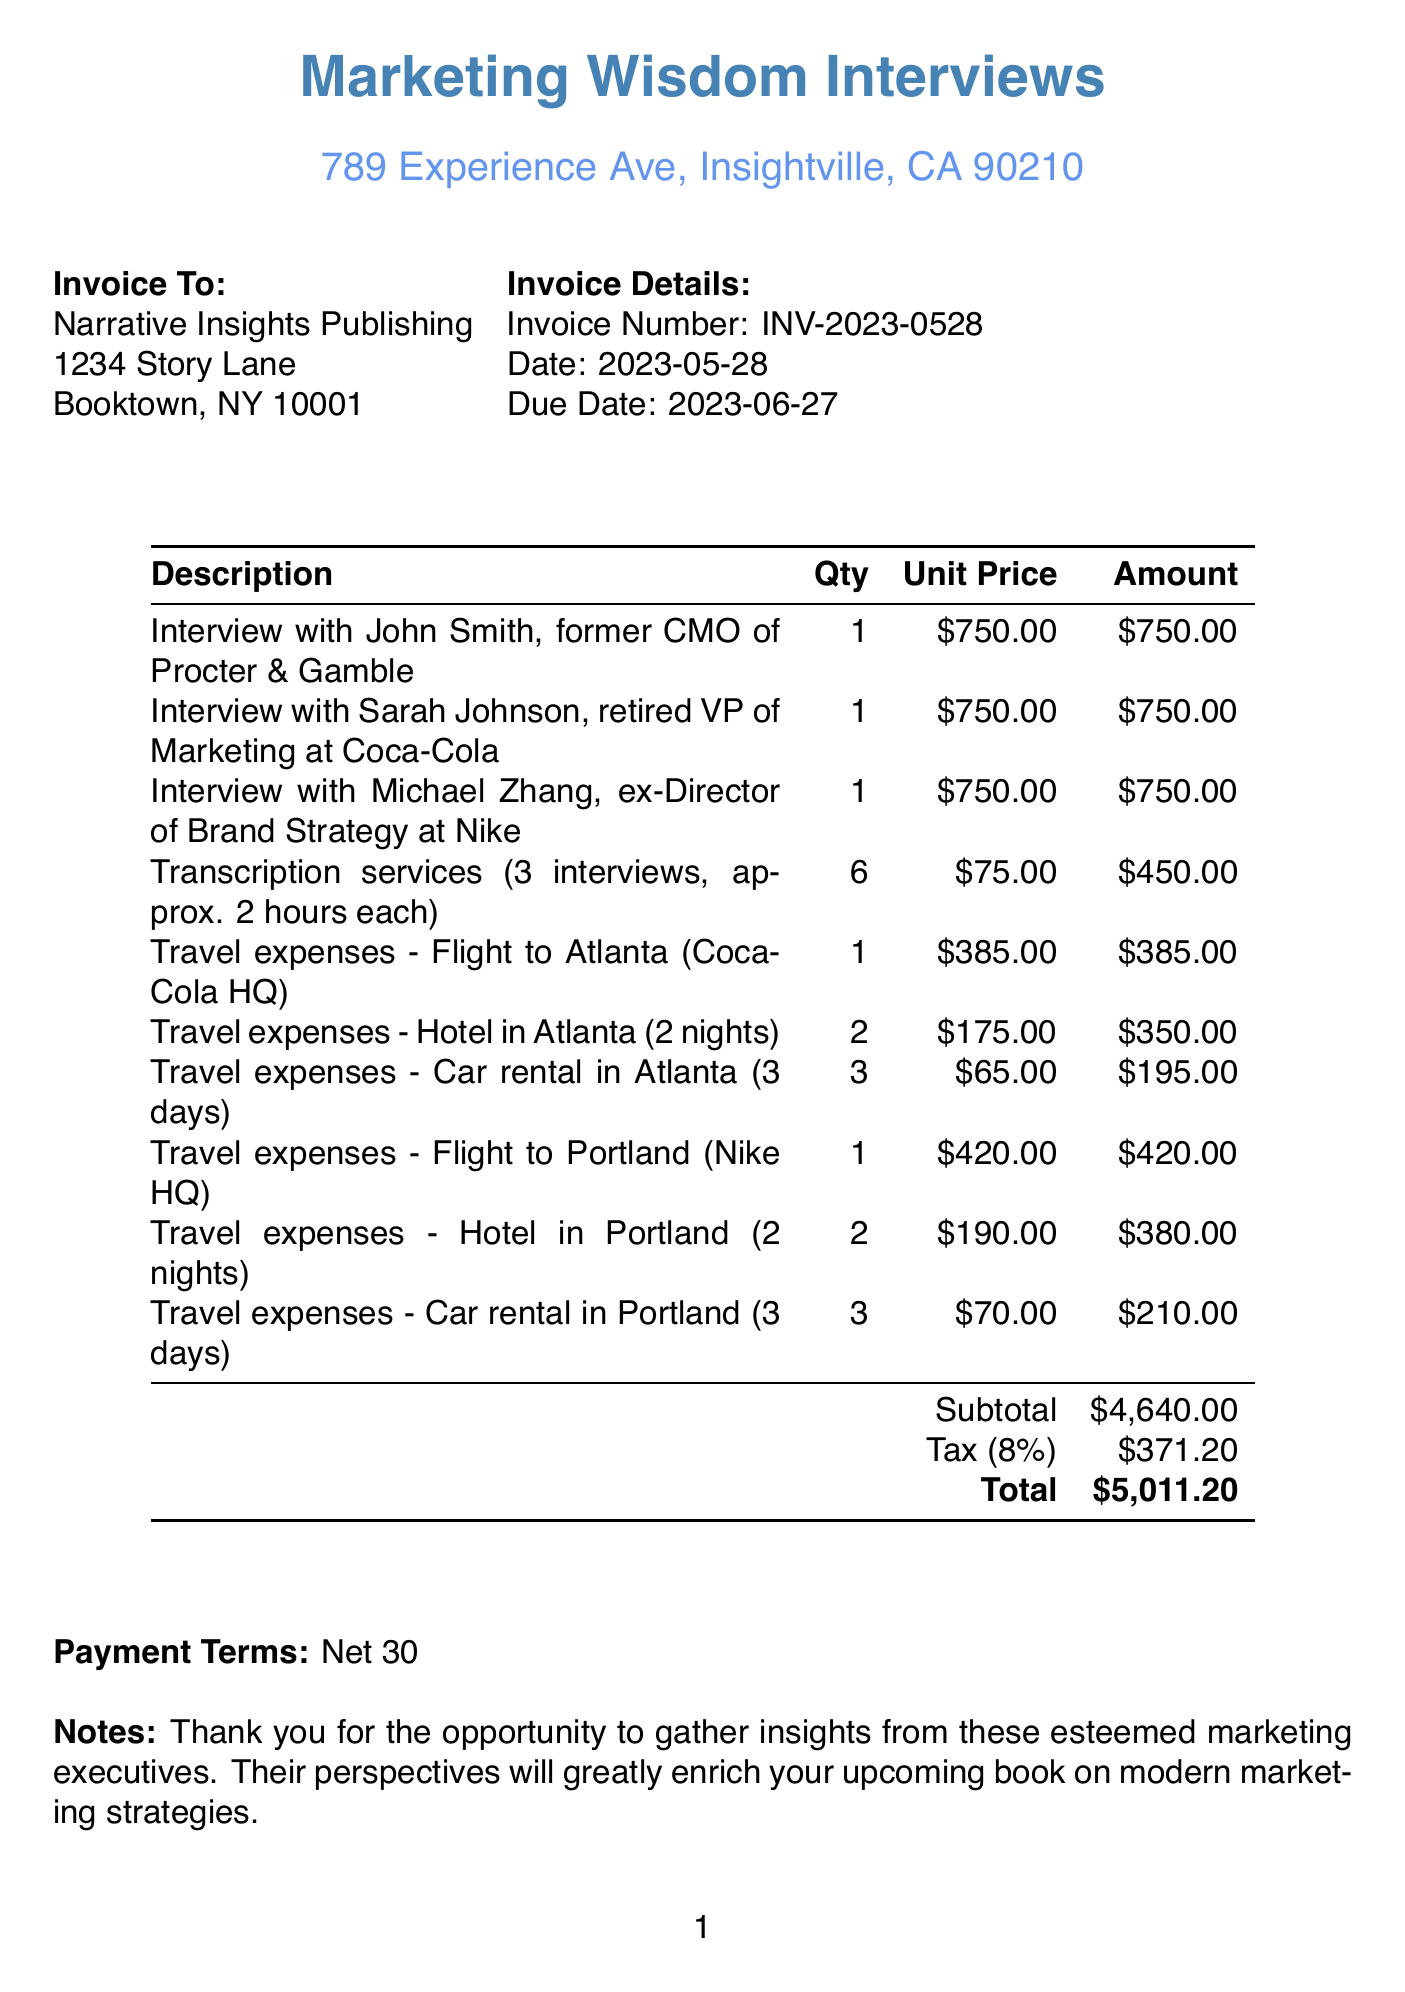What is the invoice number? The invoice number is clearly indicated in the document as INV-2023-0528.
Answer: INV-2023-0528 Who is the client? The client name is listed in the document, which is Narrative Insights Publishing.
Answer: Narrative Insights Publishing What is the due date of the invoice? The due date is specified in the invoice details section, which is 2023-06-27.
Answer: 2023-06-27 How many interviews were conducted? The invoice lists three distinct interviews with different executives, each counted as one.
Answer: 3 What is the subtotal amount before tax? The subtotal is mentioned in the document as the total of services provided, which is $4640.00.
Answer: $4640.00 What percentage is the tax rate? The tax rate is explicitly stated in the document, which is 8%.
Answer: 8% What are the payment terms specified? The payment terms are noted at the end of the document, which states "Net 30."
Answer: Net 30 Which company's former executive was interviewed for Coca-Cola? The document mentions the interview with Sarah Johnson, who is the retired VP of Marketing at Coca-Cola.
Answer: Sarah Johnson How much was spent on travel expenses for Portland? The total travel expenses for Portland include flights, hotels, and car rentals, which total to $1,380.00.
Answer: $1,380.00 